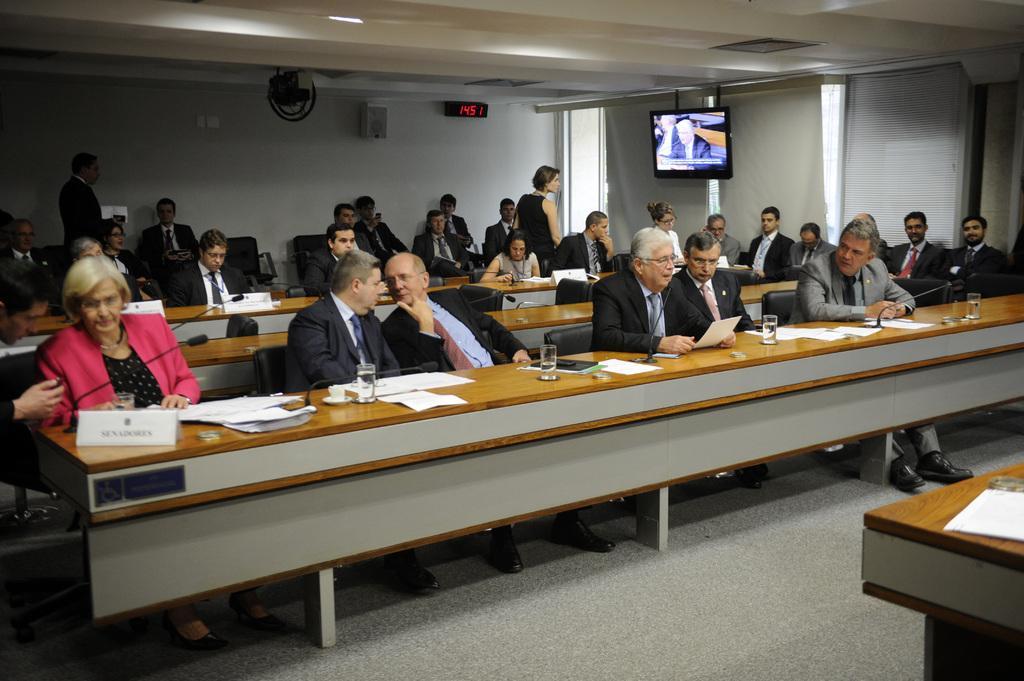Describe this image in one or two sentences. This image is clicked in a conference hall. There are many people in this image. To the left, the woman wearing pink suit is sitting. In the front, there is a table on which name plates,glasses and papers are kept. In the background, there is a wall on which TV, speaker, and a wall clock are fixed. 